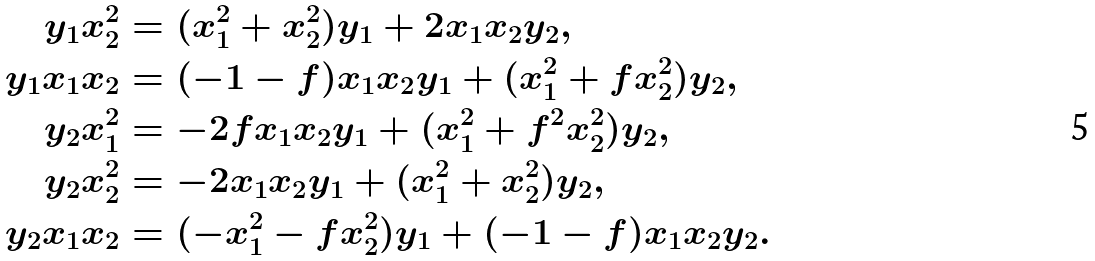<formula> <loc_0><loc_0><loc_500><loc_500>y _ { 1 } x _ { 2 } ^ { 2 } & = ( x _ { 1 } ^ { 2 } + x _ { 2 } ^ { 2 } ) y _ { 1 } + 2 x _ { 1 } x _ { 2 } y _ { 2 } , \\ y _ { 1 } x _ { 1 } x _ { 2 } & = ( - 1 - f ) x _ { 1 } x _ { 2 } y _ { 1 } + ( x _ { 1 } ^ { 2 } + f x _ { 2 } ^ { 2 } ) y _ { 2 } , \\ y _ { 2 } x _ { 1 } ^ { 2 } & = - 2 f x _ { 1 } x _ { 2 } y _ { 1 } + ( x _ { 1 } ^ { 2 } + f ^ { 2 } x _ { 2 } ^ { 2 } ) y _ { 2 } , \\ y _ { 2 } x _ { 2 } ^ { 2 } & = - 2 x _ { 1 } x _ { 2 } y _ { 1 } + ( x _ { 1 } ^ { 2 } + x _ { 2 } ^ { 2 } ) y _ { 2 } , \\ y _ { 2 } x _ { 1 } x _ { 2 } & = ( - x _ { 1 } ^ { 2 } - f x _ { 2 } ^ { 2 } ) y _ { 1 } + ( - 1 - f ) x _ { 1 } x _ { 2 } y _ { 2 } .</formula> 